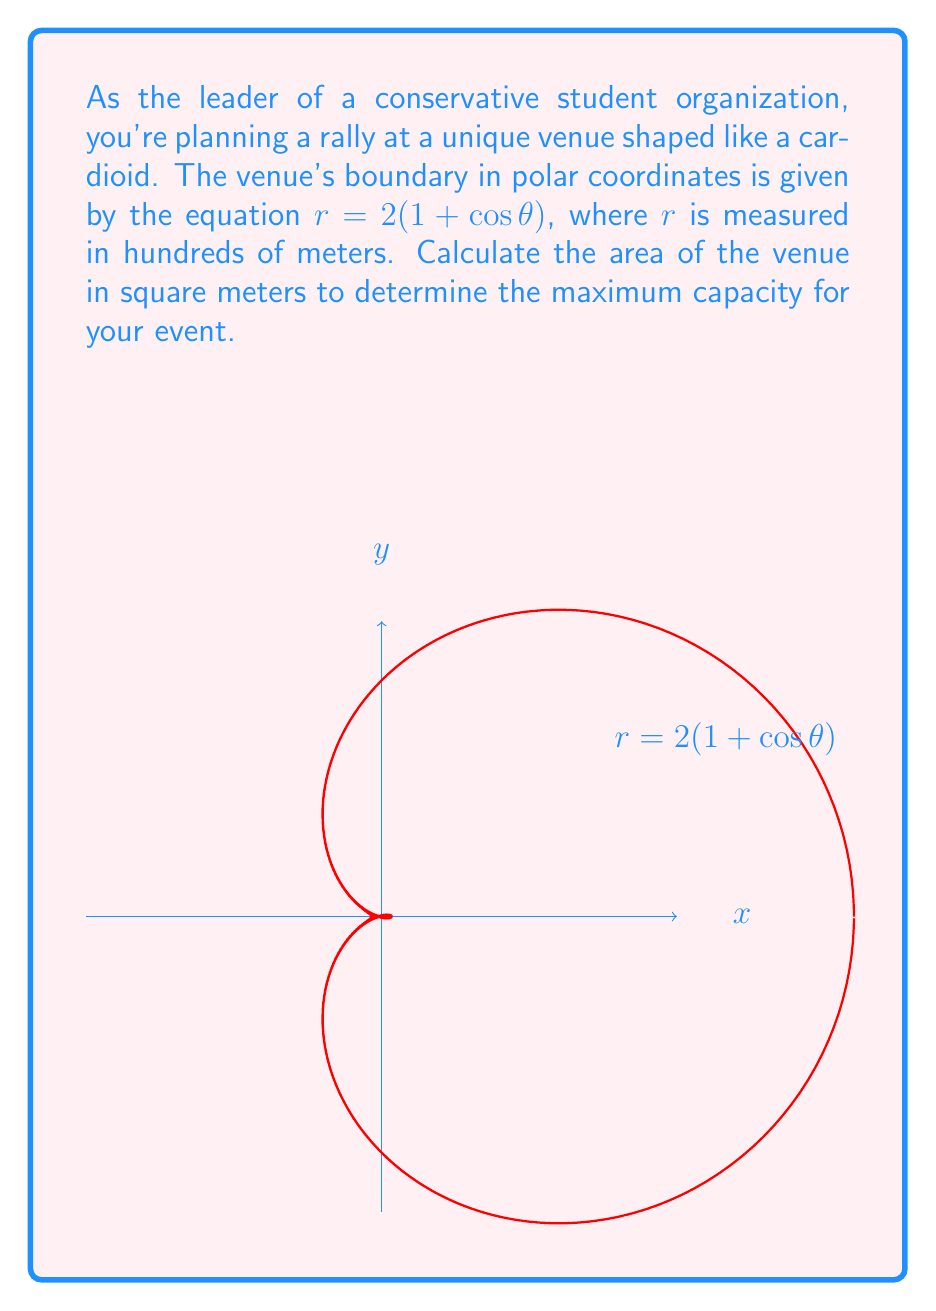Solve this math problem. To calculate the area enclosed by a polar curve, we use the formula:

$$A = \frac{1}{2} \int_0^{2\pi} r^2(\theta) d\theta$$

For our cardioid, $r = 2(1 + \cos\theta)$. Let's follow these steps:

1) Square the radius function:
   $r^2 = 4(1 + 2\cos\theta + \cos^2\theta)$

2) Substitute into the area formula:
   $$A = \frac{1}{2} \int_0^{2\pi} 4(1 + 2\cos\theta + \cos^2\theta) d\theta$$

3) Simplify:
   $$A = 2 \int_0^{2\pi} (1 + 2\cos\theta + \cos^2\theta) d\theta$$

4) Integrate term by term:
   $\int_0^{2\pi} 1 d\theta = 2\pi$
   $\int_0^{2\pi} 2\cos\theta d\theta = 0$
   $\int_0^{2\pi} \cos^2\theta d\theta = \pi$

5) Sum the results:
   $$A = 2(2\pi + 0 + \pi) = 6\pi$$

6) Remember that $r$ was measured in hundreds of meters, so we need to multiply by $100^2$ to get square meters:
   $$A = 6\pi \times 100^2 = 60,000\pi \text{ m}^2$$
Answer: $60,000\pi \text{ m}^2$ 